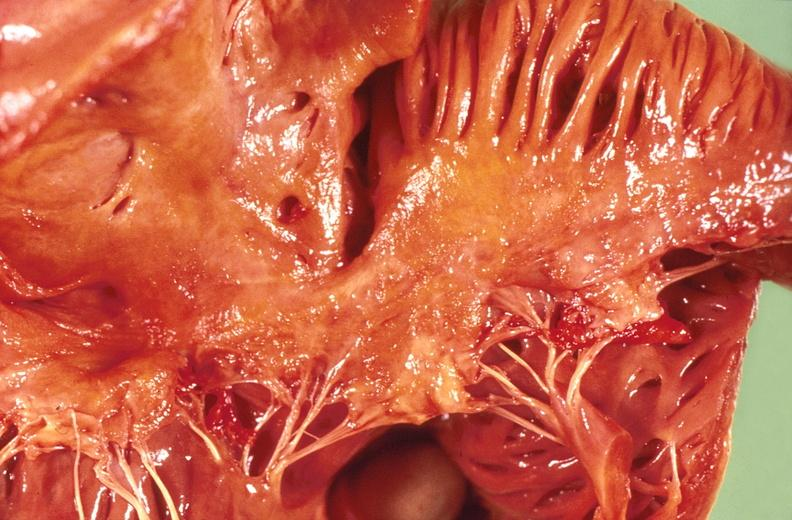s cardiovascular present?
Answer the question using a single word or phrase. Yes 